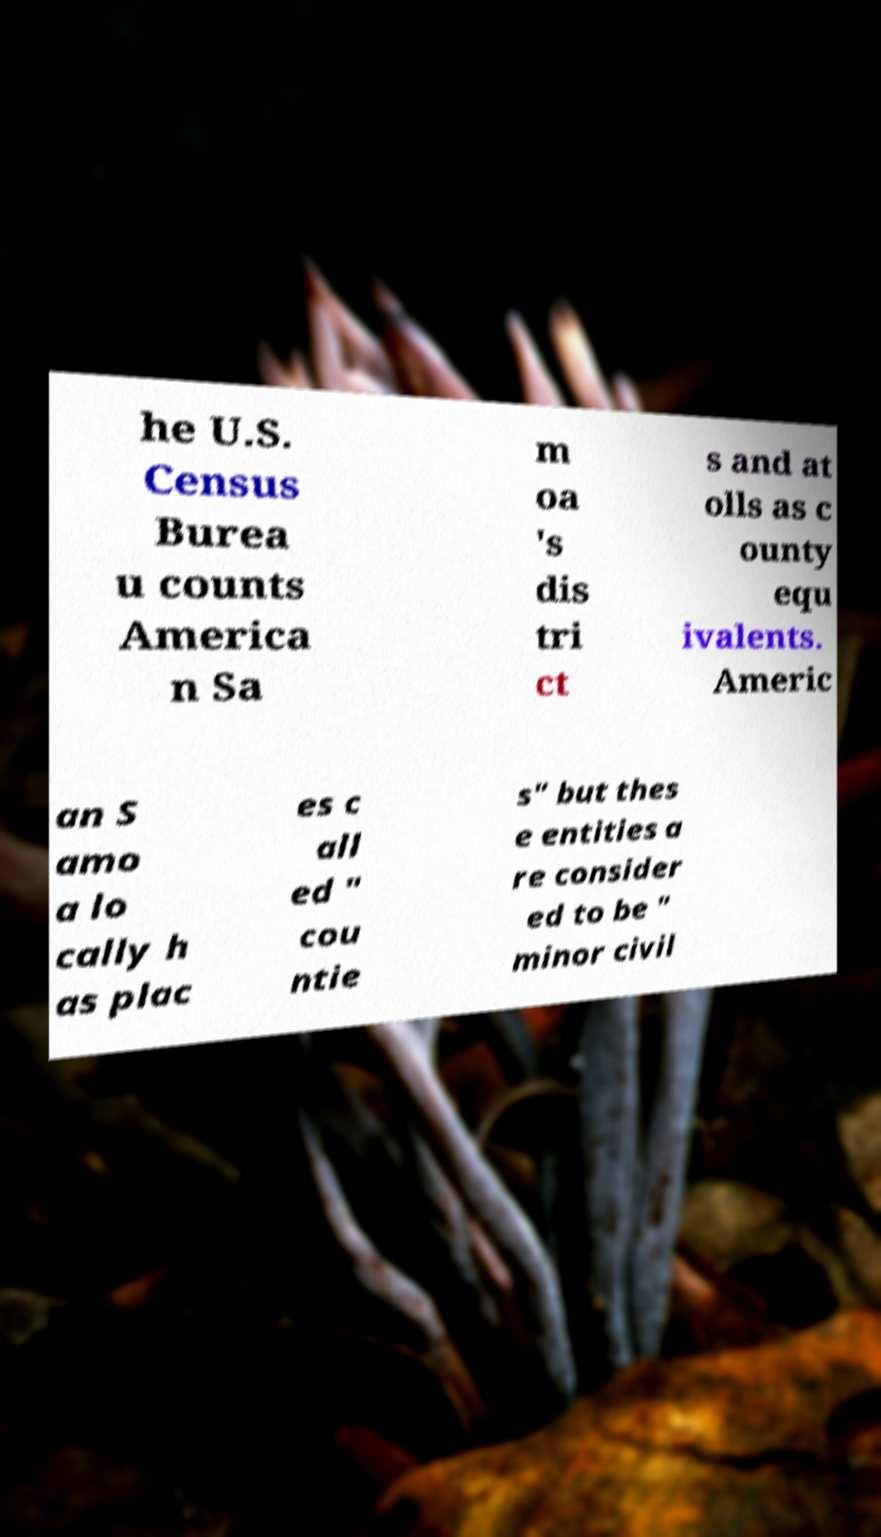There's text embedded in this image that I need extracted. Can you transcribe it verbatim? he U.S. Census Burea u counts America n Sa m oa 's dis tri ct s and at olls as c ounty equ ivalents. Americ an S amo a lo cally h as plac es c all ed " cou ntie s" but thes e entities a re consider ed to be " minor civil 